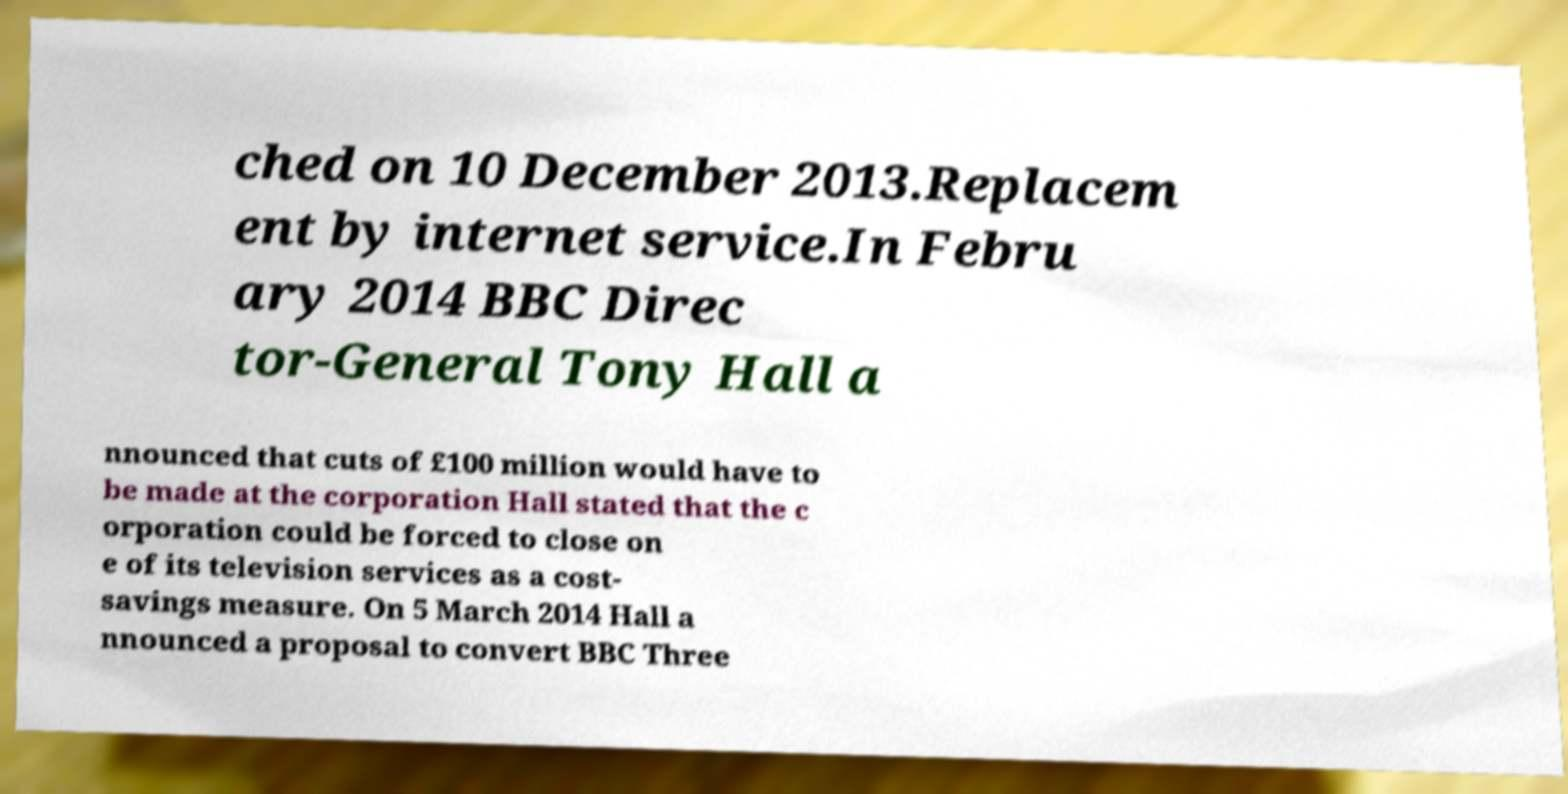Could you assist in decoding the text presented in this image and type it out clearly? ched on 10 December 2013.Replacem ent by internet service.In Febru ary 2014 BBC Direc tor-General Tony Hall a nnounced that cuts of £100 million would have to be made at the corporation Hall stated that the c orporation could be forced to close on e of its television services as a cost- savings measure. On 5 March 2014 Hall a nnounced a proposal to convert BBC Three 